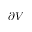<formula> <loc_0><loc_0><loc_500><loc_500>\partial V</formula> 